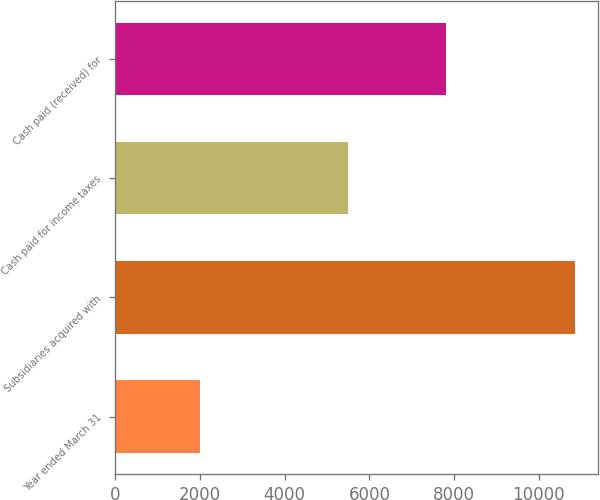<chart> <loc_0><loc_0><loc_500><loc_500><bar_chart><fcel>Year ended March 31<fcel>Subsidiaries acquired with<fcel>Cash paid for income taxes<fcel>Cash paid (received) for<nl><fcel>2003<fcel>10861<fcel>5491<fcel>7804<nl></chart> 